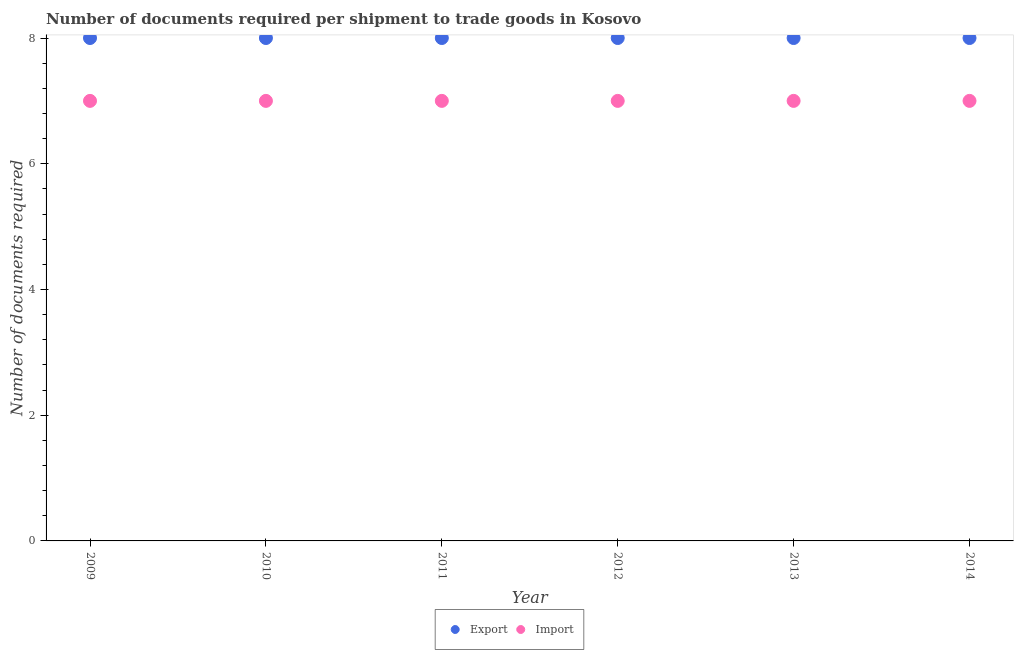Is the number of dotlines equal to the number of legend labels?
Your answer should be very brief. Yes. What is the number of documents required to import goods in 2014?
Offer a very short reply. 7. Across all years, what is the maximum number of documents required to import goods?
Ensure brevity in your answer.  7. Across all years, what is the minimum number of documents required to import goods?
Give a very brief answer. 7. In which year was the number of documents required to import goods minimum?
Your answer should be compact. 2009. What is the total number of documents required to import goods in the graph?
Your answer should be compact. 42. What is the difference between the number of documents required to export goods in 2012 and that in 2014?
Provide a short and direct response. 0. What is the difference between the number of documents required to import goods in 2014 and the number of documents required to export goods in 2009?
Your answer should be compact. -1. In the year 2013, what is the difference between the number of documents required to export goods and number of documents required to import goods?
Your answer should be very brief. 1. In how many years, is the number of documents required to import goods greater than 6?
Make the answer very short. 6. What is the ratio of the number of documents required to export goods in 2010 to that in 2013?
Provide a succinct answer. 1. Is the number of documents required to import goods in 2009 less than that in 2010?
Give a very brief answer. No. What is the difference between the highest and the lowest number of documents required to import goods?
Make the answer very short. 0. Is the sum of the number of documents required to export goods in 2009 and 2011 greater than the maximum number of documents required to import goods across all years?
Ensure brevity in your answer.  Yes. Does the number of documents required to import goods monotonically increase over the years?
Offer a terse response. No. Is the number of documents required to import goods strictly greater than the number of documents required to export goods over the years?
Provide a short and direct response. No. How many years are there in the graph?
Your answer should be compact. 6. Are the values on the major ticks of Y-axis written in scientific E-notation?
Provide a short and direct response. No. Does the graph contain grids?
Ensure brevity in your answer.  No. What is the title of the graph?
Your answer should be compact. Number of documents required per shipment to trade goods in Kosovo. Does "Investments" appear as one of the legend labels in the graph?
Offer a terse response. No. What is the label or title of the X-axis?
Your response must be concise. Year. What is the label or title of the Y-axis?
Keep it short and to the point. Number of documents required. What is the Number of documents required in Export in 2010?
Provide a short and direct response. 8. What is the Number of documents required in Import in 2012?
Ensure brevity in your answer.  7. What is the Number of documents required of Export in 2014?
Give a very brief answer. 8. Across all years, what is the maximum Number of documents required in Export?
Your response must be concise. 8. What is the total Number of documents required of Import in the graph?
Ensure brevity in your answer.  42. What is the difference between the Number of documents required in Export in 2009 and that in 2010?
Provide a succinct answer. 0. What is the difference between the Number of documents required in Export in 2009 and that in 2011?
Give a very brief answer. 0. What is the difference between the Number of documents required of Import in 2009 and that in 2011?
Your answer should be compact. 0. What is the difference between the Number of documents required in Import in 2009 and that in 2012?
Give a very brief answer. 0. What is the difference between the Number of documents required in Export in 2009 and that in 2013?
Give a very brief answer. 0. What is the difference between the Number of documents required in Import in 2009 and that in 2013?
Your response must be concise. 0. What is the difference between the Number of documents required of Import in 2009 and that in 2014?
Your answer should be compact. 0. What is the difference between the Number of documents required of Import in 2010 and that in 2011?
Ensure brevity in your answer.  0. What is the difference between the Number of documents required in Import in 2010 and that in 2012?
Provide a succinct answer. 0. What is the difference between the Number of documents required in Export in 2010 and that in 2013?
Your response must be concise. 0. What is the difference between the Number of documents required in Export in 2010 and that in 2014?
Your response must be concise. 0. What is the difference between the Number of documents required in Export in 2011 and that in 2012?
Ensure brevity in your answer.  0. What is the difference between the Number of documents required in Import in 2011 and that in 2012?
Offer a very short reply. 0. What is the difference between the Number of documents required of Export in 2011 and that in 2013?
Keep it short and to the point. 0. What is the difference between the Number of documents required of Import in 2011 and that in 2013?
Provide a succinct answer. 0. What is the difference between the Number of documents required of Export in 2011 and that in 2014?
Keep it short and to the point. 0. What is the difference between the Number of documents required in Export in 2012 and that in 2013?
Your answer should be compact. 0. What is the difference between the Number of documents required in Import in 2012 and that in 2013?
Your answer should be compact. 0. What is the difference between the Number of documents required of Export in 2009 and the Number of documents required of Import in 2012?
Ensure brevity in your answer.  1. What is the difference between the Number of documents required in Export in 2010 and the Number of documents required in Import in 2011?
Provide a succinct answer. 1. What is the difference between the Number of documents required in Export in 2010 and the Number of documents required in Import in 2012?
Provide a succinct answer. 1. What is the difference between the Number of documents required of Export in 2011 and the Number of documents required of Import in 2012?
Provide a succinct answer. 1. What is the difference between the Number of documents required in Export in 2011 and the Number of documents required in Import in 2014?
Keep it short and to the point. 1. What is the average Number of documents required in Export per year?
Provide a succinct answer. 8. What is the average Number of documents required in Import per year?
Keep it short and to the point. 7. In the year 2009, what is the difference between the Number of documents required in Export and Number of documents required in Import?
Your response must be concise. 1. In the year 2011, what is the difference between the Number of documents required in Export and Number of documents required in Import?
Your answer should be compact. 1. In the year 2012, what is the difference between the Number of documents required of Export and Number of documents required of Import?
Your response must be concise. 1. What is the ratio of the Number of documents required of Export in 2009 to that in 2011?
Provide a succinct answer. 1. What is the ratio of the Number of documents required of Import in 2009 to that in 2011?
Provide a short and direct response. 1. What is the ratio of the Number of documents required in Export in 2009 to that in 2012?
Keep it short and to the point. 1. What is the ratio of the Number of documents required in Import in 2009 to that in 2012?
Provide a short and direct response. 1. What is the ratio of the Number of documents required in Export in 2009 to that in 2013?
Ensure brevity in your answer.  1. What is the ratio of the Number of documents required in Export in 2009 to that in 2014?
Keep it short and to the point. 1. What is the ratio of the Number of documents required of Import in 2010 to that in 2011?
Offer a terse response. 1. What is the ratio of the Number of documents required in Export in 2010 to that in 2013?
Ensure brevity in your answer.  1. What is the ratio of the Number of documents required in Import in 2010 to that in 2013?
Offer a very short reply. 1. What is the ratio of the Number of documents required of Export in 2011 to that in 2012?
Your response must be concise. 1. What is the ratio of the Number of documents required in Import in 2011 to that in 2013?
Your answer should be very brief. 1. What is the ratio of the Number of documents required of Export in 2011 to that in 2014?
Provide a succinct answer. 1. What is the ratio of the Number of documents required in Export in 2012 to that in 2013?
Your response must be concise. 1. What is the difference between the highest and the lowest Number of documents required of Export?
Ensure brevity in your answer.  0. What is the difference between the highest and the lowest Number of documents required in Import?
Provide a succinct answer. 0. 